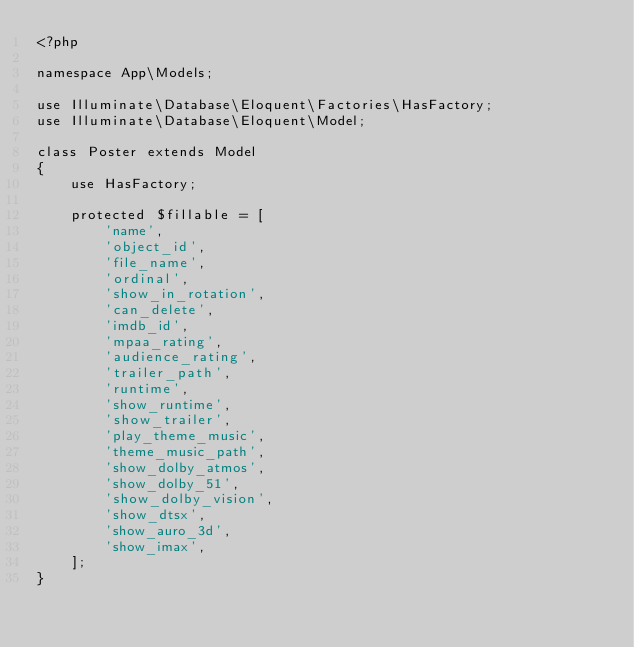<code> <loc_0><loc_0><loc_500><loc_500><_PHP_><?php

namespace App\Models;

use Illuminate\Database\Eloquent\Factories\HasFactory;
use Illuminate\Database\Eloquent\Model;

class Poster extends Model
{
    use HasFactory;

    protected $fillable = [
        'name',
        'object_id',
        'file_name',
        'ordinal',
        'show_in_rotation',
        'can_delete',
        'imdb_id',
        'mpaa_rating',
        'audience_rating',
        'trailer_path',
        'runtime',
        'show_runtime',
        'show_trailer',
        'play_theme_music',
        'theme_music_path',
        'show_dolby_atmos',
        'show_dolby_51',
        'show_dolby_vision',
        'show_dtsx',
        'show_auro_3d',
        'show_imax',
    ];
}
</code> 